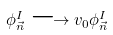Convert formula to latex. <formula><loc_0><loc_0><loc_500><loc_500>\phi ^ { I } _ { \vec { n } } \longrightarrow v _ { 0 } \phi ^ { I } _ { \vec { n } }</formula> 